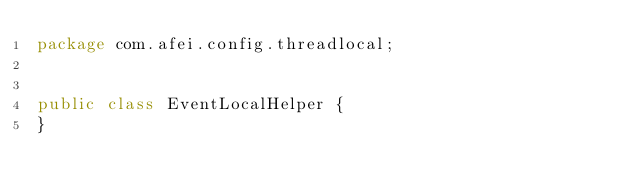Convert code to text. <code><loc_0><loc_0><loc_500><loc_500><_Java_>package com.afei.config.threadlocal;


public class EventLocalHelper {
}
</code> 